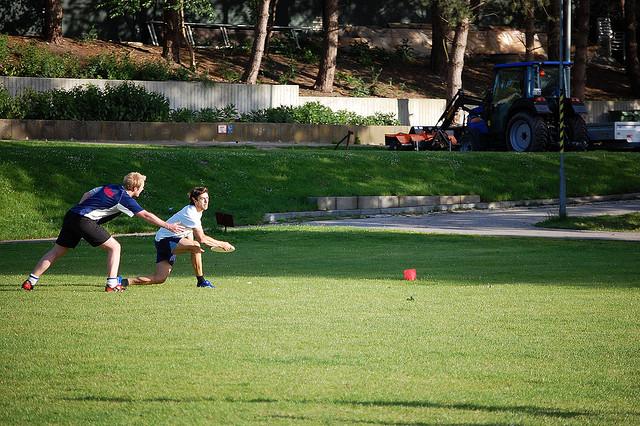Are these two men playing a game?
Be succinct. Yes. What are they doing?
Keep it brief. Playing frisbee. What game are they playing?
Write a very short answer. Frisbee. What is the red object in the middle of the lawn?
Keep it brief. Frisbee. Is there two teams?
Be succinct. Yes. Do you think this game is fun?
Short answer required. Yes. How fast is the baseball traveling?
Be succinct. No baseball. What sport is this?
Give a very brief answer. Frisbee. Is this a game?
Be succinct. Yes. Is there a bench on the sidewalk?
Answer briefly. No. Is this a multiracial game?
Answer briefly. No. 